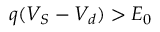<formula> <loc_0><loc_0><loc_500><loc_500>q ( V _ { S } - V _ { d } ) > E _ { 0 }</formula> 